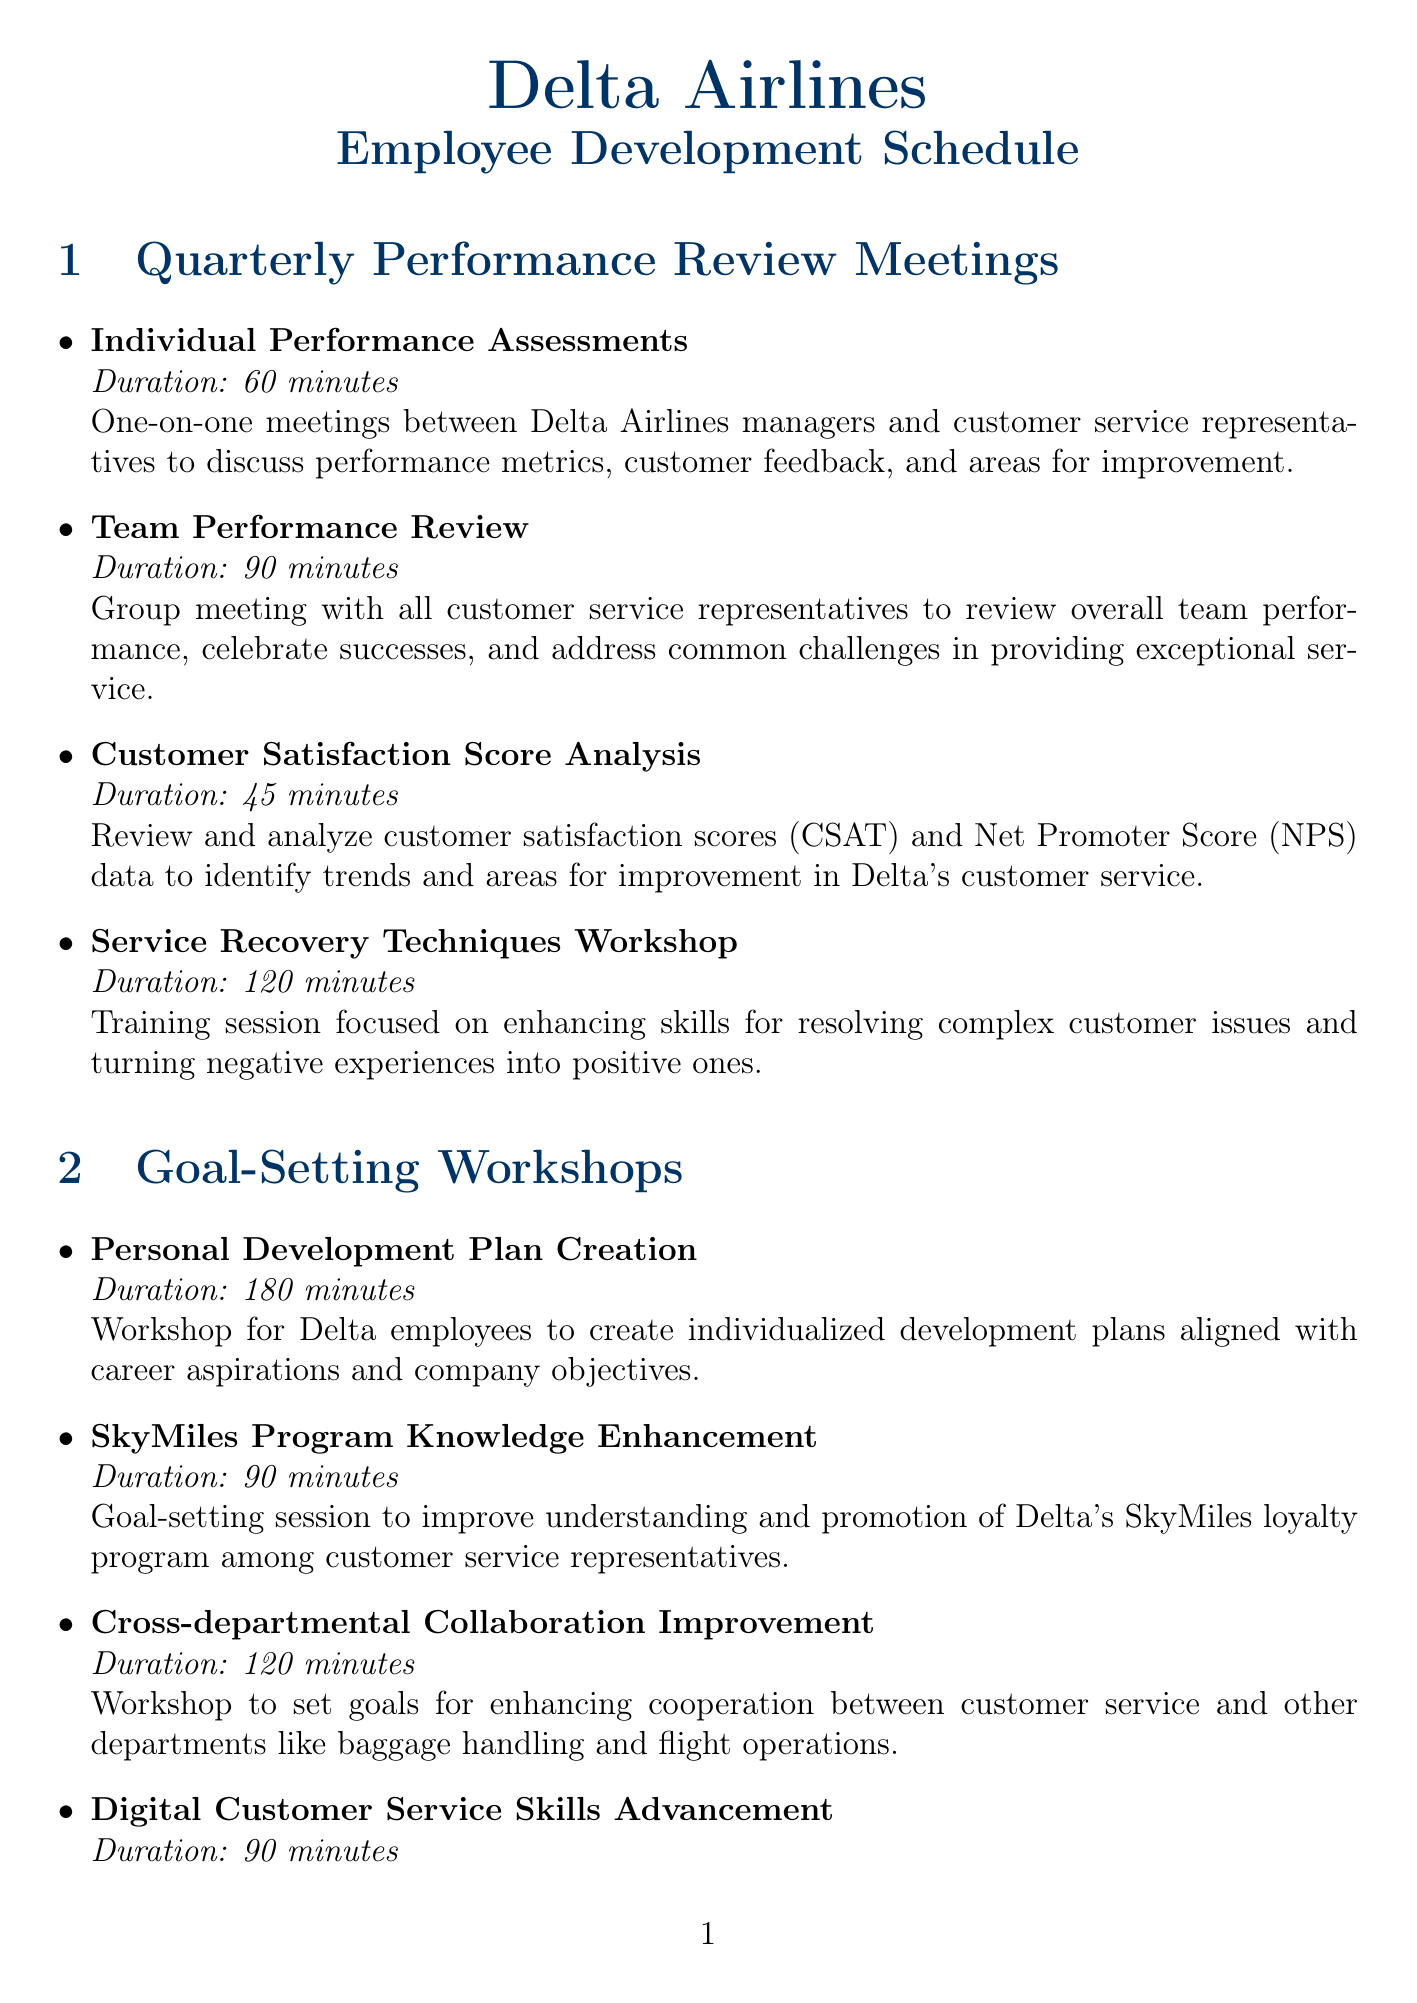What is the duration of the Individual Performance Assessments? The duration of the Individual Performance Assessments meeting is explicitly stated in the document as 60 minutes.
Answer: 60 minutes How often is the Team Performance Review conducted? The document mentions the frequency of the Team Performance Review meeting as Quarterly.
Answer: Quarterly What is the focus of the Service Recovery Techniques Workshop? The document describes that the focus of the Service Recovery Techniques Workshop is on enhancing skills for resolving complex customer issues.
Answer: Resolving complex customer issues How long is the workshop for Personal Development Plan Creation? The document explicitly states that the duration of the Personal Development Plan Creation workshop is 180 minutes.
Answer: 180 minutes What is the primary goal of the Digital Customer Service Skills Advancement session? The document indicates that the primary goal of the Digital Customer Service Skills Advancement session is to improve proficiency with Delta's digital customer service tools.
Answer: Improve proficiency with digital tools Which meeting has a duration of 120 minutes? The document lists the Service Recovery Techniques Workshop and the Cross-departmental Collaboration Improvement workshop, both of which have a duration of 120 minutes.
Answer: Service Recovery Techniques Workshop, Cross-departmental Collaboration Improvement How many goals are set during the Customer Empathy and Cultural Sensitivity Training? The document does not specify a number of goals for the Customer Empathy and Cultural Sensitivity Training, only stating it is to improve empathy and cultural awareness.
Answer: Not specified What is the main purpose of the Customer Satisfaction Score Analysis? According to the document, the main purpose of the Customer Satisfaction Score Analysis is to identify trends and areas for improvement in Delta's customer service.
Answer: Identify trends and areas for improvement Which workshop is scheduled semi-annually? The document specifies that the Customer Empathy and Cultural Sensitivity Training is scheduled semi-annually.
Answer: Customer Empathy and Cultural Sensitivity Training 